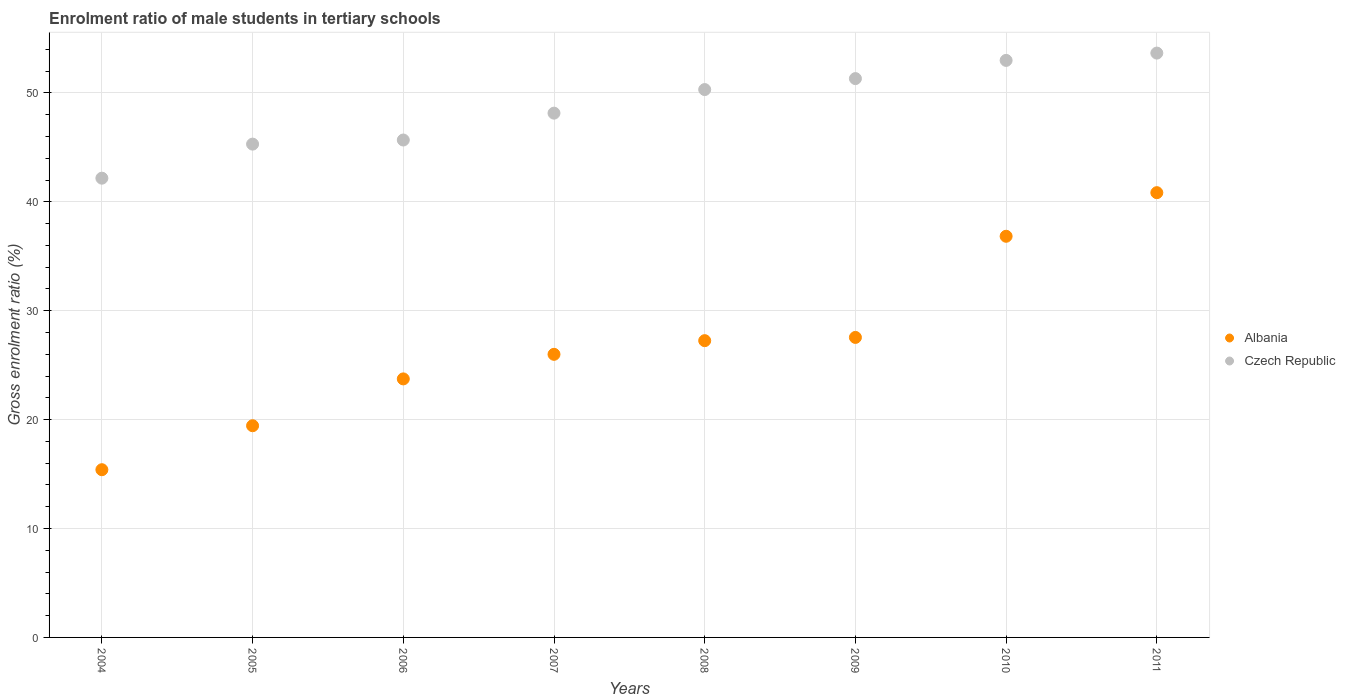How many different coloured dotlines are there?
Your answer should be very brief. 2. What is the enrolment ratio of male students in tertiary schools in Albania in 2004?
Your answer should be compact. 15.4. Across all years, what is the maximum enrolment ratio of male students in tertiary schools in Czech Republic?
Your answer should be compact. 53.67. Across all years, what is the minimum enrolment ratio of male students in tertiary schools in Czech Republic?
Your answer should be compact. 42.18. What is the total enrolment ratio of male students in tertiary schools in Albania in the graph?
Your answer should be very brief. 217.08. What is the difference between the enrolment ratio of male students in tertiary schools in Albania in 2004 and that in 2005?
Make the answer very short. -4.04. What is the difference between the enrolment ratio of male students in tertiary schools in Albania in 2009 and the enrolment ratio of male students in tertiary schools in Czech Republic in 2010?
Your answer should be compact. -25.44. What is the average enrolment ratio of male students in tertiary schools in Albania per year?
Ensure brevity in your answer.  27.14. In the year 2010, what is the difference between the enrolment ratio of male students in tertiary schools in Czech Republic and enrolment ratio of male students in tertiary schools in Albania?
Make the answer very short. 16.15. In how many years, is the enrolment ratio of male students in tertiary schools in Czech Republic greater than 4 %?
Give a very brief answer. 8. What is the ratio of the enrolment ratio of male students in tertiary schools in Albania in 2008 to that in 2009?
Make the answer very short. 0.99. Is the enrolment ratio of male students in tertiary schools in Czech Republic in 2006 less than that in 2010?
Keep it short and to the point. Yes. Is the difference between the enrolment ratio of male students in tertiary schools in Czech Republic in 2006 and 2009 greater than the difference between the enrolment ratio of male students in tertiary schools in Albania in 2006 and 2009?
Your answer should be very brief. No. What is the difference between the highest and the second highest enrolment ratio of male students in tertiary schools in Albania?
Your answer should be compact. 4. What is the difference between the highest and the lowest enrolment ratio of male students in tertiary schools in Czech Republic?
Keep it short and to the point. 11.49. In how many years, is the enrolment ratio of male students in tertiary schools in Czech Republic greater than the average enrolment ratio of male students in tertiary schools in Czech Republic taken over all years?
Provide a short and direct response. 4. Is the enrolment ratio of male students in tertiary schools in Czech Republic strictly less than the enrolment ratio of male students in tertiary schools in Albania over the years?
Your response must be concise. No. What is the difference between two consecutive major ticks on the Y-axis?
Provide a short and direct response. 10. Are the values on the major ticks of Y-axis written in scientific E-notation?
Your answer should be compact. No. What is the title of the graph?
Offer a terse response. Enrolment ratio of male students in tertiary schools. Does "Sudan" appear as one of the legend labels in the graph?
Offer a very short reply. No. What is the label or title of the X-axis?
Provide a succinct answer. Years. What is the label or title of the Y-axis?
Provide a succinct answer. Gross enrolment ratio (%). What is the Gross enrolment ratio (%) in Albania in 2004?
Offer a terse response. 15.4. What is the Gross enrolment ratio (%) of Czech Republic in 2004?
Give a very brief answer. 42.18. What is the Gross enrolment ratio (%) in Albania in 2005?
Ensure brevity in your answer.  19.44. What is the Gross enrolment ratio (%) in Czech Republic in 2005?
Your answer should be compact. 45.3. What is the Gross enrolment ratio (%) of Albania in 2006?
Offer a terse response. 23.74. What is the Gross enrolment ratio (%) in Czech Republic in 2006?
Your answer should be compact. 45.68. What is the Gross enrolment ratio (%) in Albania in 2007?
Provide a short and direct response. 26. What is the Gross enrolment ratio (%) of Czech Republic in 2007?
Ensure brevity in your answer.  48.15. What is the Gross enrolment ratio (%) of Albania in 2008?
Ensure brevity in your answer.  27.25. What is the Gross enrolment ratio (%) in Czech Republic in 2008?
Give a very brief answer. 50.31. What is the Gross enrolment ratio (%) in Albania in 2009?
Provide a short and direct response. 27.55. What is the Gross enrolment ratio (%) in Czech Republic in 2009?
Offer a very short reply. 51.32. What is the Gross enrolment ratio (%) in Albania in 2010?
Keep it short and to the point. 36.84. What is the Gross enrolment ratio (%) in Czech Republic in 2010?
Provide a short and direct response. 52.99. What is the Gross enrolment ratio (%) in Albania in 2011?
Make the answer very short. 40.85. What is the Gross enrolment ratio (%) in Czech Republic in 2011?
Provide a succinct answer. 53.67. Across all years, what is the maximum Gross enrolment ratio (%) of Albania?
Ensure brevity in your answer.  40.85. Across all years, what is the maximum Gross enrolment ratio (%) of Czech Republic?
Make the answer very short. 53.67. Across all years, what is the minimum Gross enrolment ratio (%) in Albania?
Provide a short and direct response. 15.4. Across all years, what is the minimum Gross enrolment ratio (%) in Czech Republic?
Make the answer very short. 42.18. What is the total Gross enrolment ratio (%) of Albania in the graph?
Offer a terse response. 217.08. What is the total Gross enrolment ratio (%) of Czech Republic in the graph?
Offer a very short reply. 389.61. What is the difference between the Gross enrolment ratio (%) in Albania in 2004 and that in 2005?
Offer a terse response. -4.04. What is the difference between the Gross enrolment ratio (%) of Czech Republic in 2004 and that in 2005?
Your response must be concise. -3.13. What is the difference between the Gross enrolment ratio (%) of Albania in 2004 and that in 2006?
Provide a short and direct response. -8.34. What is the difference between the Gross enrolment ratio (%) in Czech Republic in 2004 and that in 2006?
Provide a short and direct response. -3.5. What is the difference between the Gross enrolment ratio (%) of Albania in 2004 and that in 2007?
Offer a very short reply. -10.6. What is the difference between the Gross enrolment ratio (%) in Czech Republic in 2004 and that in 2007?
Give a very brief answer. -5.97. What is the difference between the Gross enrolment ratio (%) in Albania in 2004 and that in 2008?
Keep it short and to the point. -11.85. What is the difference between the Gross enrolment ratio (%) in Czech Republic in 2004 and that in 2008?
Your answer should be very brief. -8.14. What is the difference between the Gross enrolment ratio (%) in Albania in 2004 and that in 2009?
Provide a short and direct response. -12.15. What is the difference between the Gross enrolment ratio (%) in Czech Republic in 2004 and that in 2009?
Your response must be concise. -9.14. What is the difference between the Gross enrolment ratio (%) of Albania in 2004 and that in 2010?
Your response must be concise. -21.44. What is the difference between the Gross enrolment ratio (%) in Czech Republic in 2004 and that in 2010?
Make the answer very short. -10.82. What is the difference between the Gross enrolment ratio (%) of Albania in 2004 and that in 2011?
Offer a terse response. -25.44. What is the difference between the Gross enrolment ratio (%) in Czech Republic in 2004 and that in 2011?
Provide a short and direct response. -11.49. What is the difference between the Gross enrolment ratio (%) of Albania in 2005 and that in 2006?
Make the answer very short. -4.3. What is the difference between the Gross enrolment ratio (%) in Czech Republic in 2005 and that in 2006?
Ensure brevity in your answer.  -0.38. What is the difference between the Gross enrolment ratio (%) in Albania in 2005 and that in 2007?
Your response must be concise. -6.56. What is the difference between the Gross enrolment ratio (%) of Czech Republic in 2005 and that in 2007?
Make the answer very short. -2.84. What is the difference between the Gross enrolment ratio (%) in Albania in 2005 and that in 2008?
Your answer should be very brief. -7.81. What is the difference between the Gross enrolment ratio (%) in Czech Republic in 2005 and that in 2008?
Offer a very short reply. -5.01. What is the difference between the Gross enrolment ratio (%) of Albania in 2005 and that in 2009?
Keep it short and to the point. -8.11. What is the difference between the Gross enrolment ratio (%) of Czech Republic in 2005 and that in 2009?
Provide a succinct answer. -6.02. What is the difference between the Gross enrolment ratio (%) of Albania in 2005 and that in 2010?
Offer a terse response. -17.4. What is the difference between the Gross enrolment ratio (%) in Czech Republic in 2005 and that in 2010?
Keep it short and to the point. -7.69. What is the difference between the Gross enrolment ratio (%) in Albania in 2005 and that in 2011?
Keep it short and to the point. -21.4. What is the difference between the Gross enrolment ratio (%) of Czech Republic in 2005 and that in 2011?
Offer a very short reply. -8.36. What is the difference between the Gross enrolment ratio (%) in Albania in 2006 and that in 2007?
Offer a terse response. -2.26. What is the difference between the Gross enrolment ratio (%) of Czech Republic in 2006 and that in 2007?
Your answer should be compact. -2.47. What is the difference between the Gross enrolment ratio (%) in Albania in 2006 and that in 2008?
Give a very brief answer. -3.51. What is the difference between the Gross enrolment ratio (%) of Czech Republic in 2006 and that in 2008?
Keep it short and to the point. -4.63. What is the difference between the Gross enrolment ratio (%) of Albania in 2006 and that in 2009?
Your answer should be compact. -3.81. What is the difference between the Gross enrolment ratio (%) of Czech Republic in 2006 and that in 2009?
Make the answer very short. -5.64. What is the difference between the Gross enrolment ratio (%) of Albania in 2006 and that in 2010?
Your response must be concise. -13.1. What is the difference between the Gross enrolment ratio (%) in Czech Republic in 2006 and that in 2010?
Ensure brevity in your answer.  -7.31. What is the difference between the Gross enrolment ratio (%) in Albania in 2006 and that in 2011?
Give a very brief answer. -17.1. What is the difference between the Gross enrolment ratio (%) in Czech Republic in 2006 and that in 2011?
Your answer should be compact. -7.98. What is the difference between the Gross enrolment ratio (%) in Albania in 2007 and that in 2008?
Make the answer very short. -1.26. What is the difference between the Gross enrolment ratio (%) in Czech Republic in 2007 and that in 2008?
Give a very brief answer. -2.17. What is the difference between the Gross enrolment ratio (%) in Albania in 2007 and that in 2009?
Give a very brief answer. -1.55. What is the difference between the Gross enrolment ratio (%) in Czech Republic in 2007 and that in 2009?
Give a very brief answer. -3.17. What is the difference between the Gross enrolment ratio (%) in Albania in 2007 and that in 2010?
Offer a very short reply. -10.84. What is the difference between the Gross enrolment ratio (%) of Czech Republic in 2007 and that in 2010?
Offer a very short reply. -4.85. What is the difference between the Gross enrolment ratio (%) in Albania in 2007 and that in 2011?
Your response must be concise. -14.85. What is the difference between the Gross enrolment ratio (%) in Czech Republic in 2007 and that in 2011?
Make the answer very short. -5.52. What is the difference between the Gross enrolment ratio (%) in Albania in 2008 and that in 2009?
Offer a very short reply. -0.3. What is the difference between the Gross enrolment ratio (%) in Czech Republic in 2008 and that in 2009?
Make the answer very short. -1.01. What is the difference between the Gross enrolment ratio (%) of Albania in 2008 and that in 2010?
Your answer should be compact. -9.59. What is the difference between the Gross enrolment ratio (%) in Czech Republic in 2008 and that in 2010?
Your answer should be compact. -2.68. What is the difference between the Gross enrolment ratio (%) of Albania in 2008 and that in 2011?
Give a very brief answer. -13.59. What is the difference between the Gross enrolment ratio (%) of Czech Republic in 2008 and that in 2011?
Give a very brief answer. -3.35. What is the difference between the Gross enrolment ratio (%) in Albania in 2009 and that in 2010?
Your answer should be compact. -9.29. What is the difference between the Gross enrolment ratio (%) in Czech Republic in 2009 and that in 2010?
Your answer should be very brief. -1.67. What is the difference between the Gross enrolment ratio (%) of Albania in 2009 and that in 2011?
Your answer should be very brief. -13.29. What is the difference between the Gross enrolment ratio (%) in Czech Republic in 2009 and that in 2011?
Your answer should be very brief. -2.34. What is the difference between the Gross enrolment ratio (%) in Albania in 2010 and that in 2011?
Your answer should be very brief. -4. What is the difference between the Gross enrolment ratio (%) of Czech Republic in 2010 and that in 2011?
Offer a terse response. -0.67. What is the difference between the Gross enrolment ratio (%) in Albania in 2004 and the Gross enrolment ratio (%) in Czech Republic in 2005?
Ensure brevity in your answer.  -29.9. What is the difference between the Gross enrolment ratio (%) in Albania in 2004 and the Gross enrolment ratio (%) in Czech Republic in 2006?
Give a very brief answer. -30.28. What is the difference between the Gross enrolment ratio (%) of Albania in 2004 and the Gross enrolment ratio (%) of Czech Republic in 2007?
Your answer should be very brief. -32.75. What is the difference between the Gross enrolment ratio (%) of Albania in 2004 and the Gross enrolment ratio (%) of Czech Republic in 2008?
Ensure brevity in your answer.  -34.91. What is the difference between the Gross enrolment ratio (%) of Albania in 2004 and the Gross enrolment ratio (%) of Czech Republic in 2009?
Offer a terse response. -35.92. What is the difference between the Gross enrolment ratio (%) of Albania in 2004 and the Gross enrolment ratio (%) of Czech Republic in 2010?
Provide a short and direct response. -37.59. What is the difference between the Gross enrolment ratio (%) in Albania in 2004 and the Gross enrolment ratio (%) in Czech Republic in 2011?
Keep it short and to the point. -38.26. What is the difference between the Gross enrolment ratio (%) in Albania in 2005 and the Gross enrolment ratio (%) in Czech Republic in 2006?
Your answer should be very brief. -26.24. What is the difference between the Gross enrolment ratio (%) of Albania in 2005 and the Gross enrolment ratio (%) of Czech Republic in 2007?
Provide a short and direct response. -28.71. What is the difference between the Gross enrolment ratio (%) in Albania in 2005 and the Gross enrolment ratio (%) in Czech Republic in 2008?
Ensure brevity in your answer.  -30.87. What is the difference between the Gross enrolment ratio (%) in Albania in 2005 and the Gross enrolment ratio (%) in Czech Republic in 2009?
Keep it short and to the point. -31.88. What is the difference between the Gross enrolment ratio (%) of Albania in 2005 and the Gross enrolment ratio (%) of Czech Republic in 2010?
Ensure brevity in your answer.  -33.55. What is the difference between the Gross enrolment ratio (%) in Albania in 2005 and the Gross enrolment ratio (%) in Czech Republic in 2011?
Offer a very short reply. -34.22. What is the difference between the Gross enrolment ratio (%) of Albania in 2006 and the Gross enrolment ratio (%) of Czech Republic in 2007?
Keep it short and to the point. -24.41. What is the difference between the Gross enrolment ratio (%) of Albania in 2006 and the Gross enrolment ratio (%) of Czech Republic in 2008?
Your answer should be compact. -26.57. What is the difference between the Gross enrolment ratio (%) of Albania in 2006 and the Gross enrolment ratio (%) of Czech Republic in 2009?
Provide a short and direct response. -27.58. What is the difference between the Gross enrolment ratio (%) of Albania in 2006 and the Gross enrolment ratio (%) of Czech Republic in 2010?
Give a very brief answer. -29.25. What is the difference between the Gross enrolment ratio (%) in Albania in 2006 and the Gross enrolment ratio (%) in Czech Republic in 2011?
Your answer should be very brief. -29.92. What is the difference between the Gross enrolment ratio (%) of Albania in 2007 and the Gross enrolment ratio (%) of Czech Republic in 2008?
Your answer should be very brief. -24.32. What is the difference between the Gross enrolment ratio (%) of Albania in 2007 and the Gross enrolment ratio (%) of Czech Republic in 2009?
Offer a very short reply. -25.32. What is the difference between the Gross enrolment ratio (%) of Albania in 2007 and the Gross enrolment ratio (%) of Czech Republic in 2010?
Your response must be concise. -26.99. What is the difference between the Gross enrolment ratio (%) of Albania in 2007 and the Gross enrolment ratio (%) of Czech Republic in 2011?
Ensure brevity in your answer.  -27.67. What is the difference between the Gross enrolment ratio (%) in Albania in 2008 and the Gross enrolment ratio (%) in Czech Republic in 2009?
Offer a very short reply. -24.07. What is the difference between the Gross enrolment ratio (%) of Albania in 2008 and the Gross enrolment ratio (%) of Czech Republic in 2010?
Offer a terse response. -25.74. What is the difference between the Gross enrolment ratio (%) in Albania in 2008 and the Gross enrolment ratio (%) in Czech Republic in 2011?
Your response must be concise. -26.41. What is the difference between the Gross enrolment ratio (%) in Albania in 2009 and the Gross enrolment ratio (%) in Czech Republic in 2010?
Keep it short and to the point. -25.44. What is the difference between the Gross enrolment ratio (%) of Albania in 2009 and the Gross enrolment ratio (%) of Czech Republic in 2011?
Provide a short and direct response. -26.11. What is the difference between the Gross enrolment ratio (%) of Albania in 2010 and the Gross enrolment ratio (%) of Czech Republic in 2011?
Offer a very short reply. -16.82. What is the average Gross enrolment ratio (%) of Albania per year?
Make the answer very short. 27.14. What is the average Gross enrolment ratio (%) in Czech Republic per year?
Your answer should be very brief. 48.7. In the year 2004, what is the difference between the Gross enrolment ratio (%) in Albania and Gross enrolment ratio (%) in Czech Republic?
Give a very brief answer. -26.77. In the year 2005, what is the difference between the Gross enrolment ratio (%) of Albania and Gross enrolment ratio (%) of Czech Republic?
Give a very brief answer. -25.86. In the year 2006, what is the difference between the Gross enrolment ratio (%) of Albania and Gross enrolment ratio (%) of Czech Republic?
Ensure brevity in your answer.  -21.94. In the year 2007, what is the difference between the Gross enrolment ratio (%) in Albania and Gross enrolment ratio (%) in Czech Republic?
Provide a short and direct response. -22.15. In the year 2008, what is the difference between the Gross enrolment ratio (%) of Albania and Gross enrolment ratio (%) of Czech Republic?
Ensure brevity in your answer.  -23.06. In the year 2009, what is the difference between the Gross enrolment ratio (%) of Albania and Gross enrolment ratio (%) of Czech Republic?
Offer a terse response. -23.77. In the year 2010, what is the difference between the Gross enrolment ratio (%) of Albania and Gross enrolment ratio (%) of Czech Republic?
Make the answer very short. -16.15. In the year 2011, what is the difference between the Gross enrolment ratio (%) of Albania and Gross enrolment ratio (%) of Czech Republic?
Your answer should be compact. -12.82. What is the ratio of the Gross enrolment ratio (%) of Albania in 2004 to that in 2005?
Give a very brief answer. 0.79. What is the ratio of the Gross enrolment ratio (%) in Albania in 2004 to that in 2006?
Your response must be concise. 0.65. What is the ratio of the Gross enrolment ratio (%) of Czech Republic in 2004 to that in 2006?
Make the answer very short. 0.92. What is the ratio of the Gross enrolment ratio (%) of Albania in 2004 to that in 2007?
Keep it short and to the point. 0.59. What is the ratio of the Gross enrolment ratio (%) of Czech Republic in 2004 to that in 2007?
Give a very brief answer. 0.88. What is the ratio of the Gross enrolment ratio (%) of Albania in 2004 to that in 2008?
Your response must be concise. 0.57. What is the ratio of the Gross enrolment ratio (%) of Czech Republic in 2004 to that in 2008?
Ensure brevity in your answer.  0.84. What is the ratio of the Gross enrolment ratio (%) of Albania in 2004 to that in 2009?
Offer a terse response. 0.56. What is the ratio of the Gross enrolment ratio (%) of Czech Republic in 2004 to that in 2009?
Provide a short and direct response. 0.82. What is the ratio of the Gross enrolment ratio (%) of Albania in 2004 to that in 2010?
Make the answer very short. 0.42. What is the ratio of the Gross enrolment ratio (%) of Czech Republic in 2004 to that in 2010?
Ensure brevity in your answer.  0.8. What is the ratio of the Gross enrolment ratio (%) of Albania in 2004 to that in 2011?
Provide a succinct answer. 0.38. What is the ratio of the Gross enrolment ratio (%) of Czech Republic in 2004 to that in 2011?
Offer a very short reply. 0.79. What is the ratio of the Gross enrolment ratio (%) in Albania in 2005 to that in 2006?
Offer a terse response. 0.82. What is the ratio of the Gross enrolment ratio (%) in Czech Republic in 2005 to that in 2006?
Offer a terse response. 0.99. What is the ratio of the Gross enrolment ratio (%) of Albania in 2005 to that in 2007?
Offer a terse response. 0.75. What is the ratio of the Gross enrolment ratio (%) of Czech Republic in 2005 to that in 2007?
Give a very brief answer. 0.94. What is the ratio of the Gross enrolment ratio (%) of Albania in 2005 to that in 2008?
Your response must be concise. 0.71. What is the ratio of the Gross enrolment ratio (%) in Czech Republic in 2005 to that in 2008?
Your answer should be compact. 0.9. What is the ratio of the Gross enrolment ratio (%) of Albania in 2005 to that in 2009?
Keep it short and to the point. 0.71. What is the ratio of the Gross enrolment ratio (%) in Czech Republic in 2005 to that in 2009?
Your answer should be compact. 0.88. What is the ratio of the Gross enrolment ratio (%) in Albania in 2005 to that in 2010?
Provide a succinct answer. 0.53. What is the ratio of the Gross enrolment ratio (%) of Czech Republic in 2005 to that in 2010?
Offer a very short reply. 0.85. What is the ratio of the Gross enrolment ratio (%) of Albania in 2005 to that in 2011?
Your answer should be compact. 0.48. What is the ratio of the Gross enrolment ratio (%) in Czech Republic in 2005 to that in 2011?
Give a very brief answer. 0.84. What is the ratio of the Gross enrolment ratio (%) of Albania in 2006 to that in 2007?
Provide a succinct answer. 0.91. What is the ratio of the Gross enrolment ratio (%) in Czech Republic in 2006 to that in 2007?
Your answer should be very brief. 0.95. What is the ratio of the Gross enrolment ratio (%) in Albania in 2006 to that in 2008?
Your answer should be very brief. 0.87. What is the ratio of the Gross enrolment ratio (%) of Czech Republic in 2006 to that in 2008?
Keep it short and to the point. 0.91. What is the ratio of the Gross enrolment ratio (%) of Albania in 2006 to that in 2009?
Keep it short and to the point. 0.86. What is the ratio of the Gross enrolment ratio (%) in Czech Republic in 2006 to that in 2009?
Give a very brief answer. 0.89. What is the ratio of the Gross enrolment ratio (%) in Albania in 2006 to that in 2010?
Your answer should be compact. 0.64. What is the ratio of the Gross enrolment ratio (%) of Czech Republic in 2006 to that in 2010?
Provide a succinct answer. 0.86. What is the ratio of the Gross enrolment ratio (%) in Albania in 2006 to that in 2011?
Ensure brevity in your answer.  0.58. What is the ratio of the Gross enrolment ratio (%) in Czech Republic in 2006 to that in 2011?
Ensure brevity in your answer.  0.85. What is the ratio of the Gross enrolment ratio (%) of Albania in 2007 to that in 2008?
Ensure brevity in your answer.  0.95. What is the ratio of the Gross enrolment ratio (%) of Czech Republic in 2007 to that in 2008?
Your answer should be very brief. 0.96. What is the ratio of the Gross enrolment ratio (%) of Albania in 2007 to that in 2009?
Ensure brevity in your answer.  0.94. What is the ratio of the Gross enrolment ratio (%) of Czech Republic in 2007 to that in 2009?
Give a very brief answer. 0.94. What is the ratio of the Gross enrolment ratio (%) in Albania in 2007 to that in 2010?
Make the answer very short. 0.71. What is the ratio of the Gross enrolment ratio (%) of Czech Republic in 2007 to that in 2010?
Keep it short and to the point. 0.91. What is the ratio of the Gross enrolment ratio (%) in Albania in 2007 to that in 2011?
Your answer should be compact. 0.64. What is the ratio of the Gross enrolment ratio (%) of Czech Republic in 2007 to that in 2011?
Your response must be concise. 0.9. What is the ratio of the Gross enrolment ratio (%) of Albania in 2008 to that in 2009?
Offer a terse response. 0.99. What is the ratio of the Gross enrolment ratio (%) in Czech Republic in 2008 to that in 2009?
Your answer should be very brief. 0.98. What is the ratio of the Gross enrolment ratio (%) in Albania in 2008 to that in 2010?
Offer a terse response. 0.74. What is the ratio of the Gross enrolment ratio (%) of Czech Republic in 2008 to that in 2010?
Your answer should be very brief. 0.95. What is the ratio of the Gross enrolment ratio (%) of Albania in 2008 to that in 2011?
Your answer should be compact. 0.67. What is the ratio of the Gross enrolment ratio (%) in Czech Republic in 2008 to that in 2011?
Your answer should be very brief. 0.94. What is the ratio of the Gross enrolment ratio (%) in Albania in 2009 to that in 2010?
Keep it short and to the point. 0.75. What is the ratio of the Gross enrolment ratio (%) of Czech Republic in 2009 to that in 2010?
Give a very brief answer. 0.97. What is the ratio of the Gross enrolment ratio (%) of Albania in 2009 to that in 2011?
Your answer should be very brief. 0.67. What is the ratio of the Gross enrolment ratio (%) of Czech Republic in 2009 to that in 2011?
Your answer should be compact. 0.96. What is the ratio of the Gross enrolment ratio (%) in Albania in 2010 to that in 2011?
Provide a short and direct response. 0.9. What is the ratio of the Gross enrolment ratio (%) in Czech Republic in 2010 to that in 2011?
Make the answer very short. 0.99. What is the difference between the highest and the second highest Gross enrolment ratio (%) of Albania?
Give a very brief answer. 4. What is the difference between the highest and the second highest Gross enrolment ratio (%) of Czech Republic?
Make the answer very short. 0.67. What is the difference between the highest and the lowest Gross enrolment ratio (%) in Albania?
Offer a very short reply. 25.44. What is the difference between the highest and the lowest Gross enrolment ratio (%) of Czech Republic?
Your answer should be compact. 11.49. 